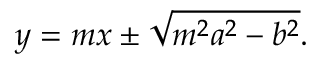<formula> <loc_0><loc_0><loc_500><loc_500>y = m x \pm { \sqrt { m ^ { 2 } a ^ { 2 } - b ^ { 2 } } } .</formula> 